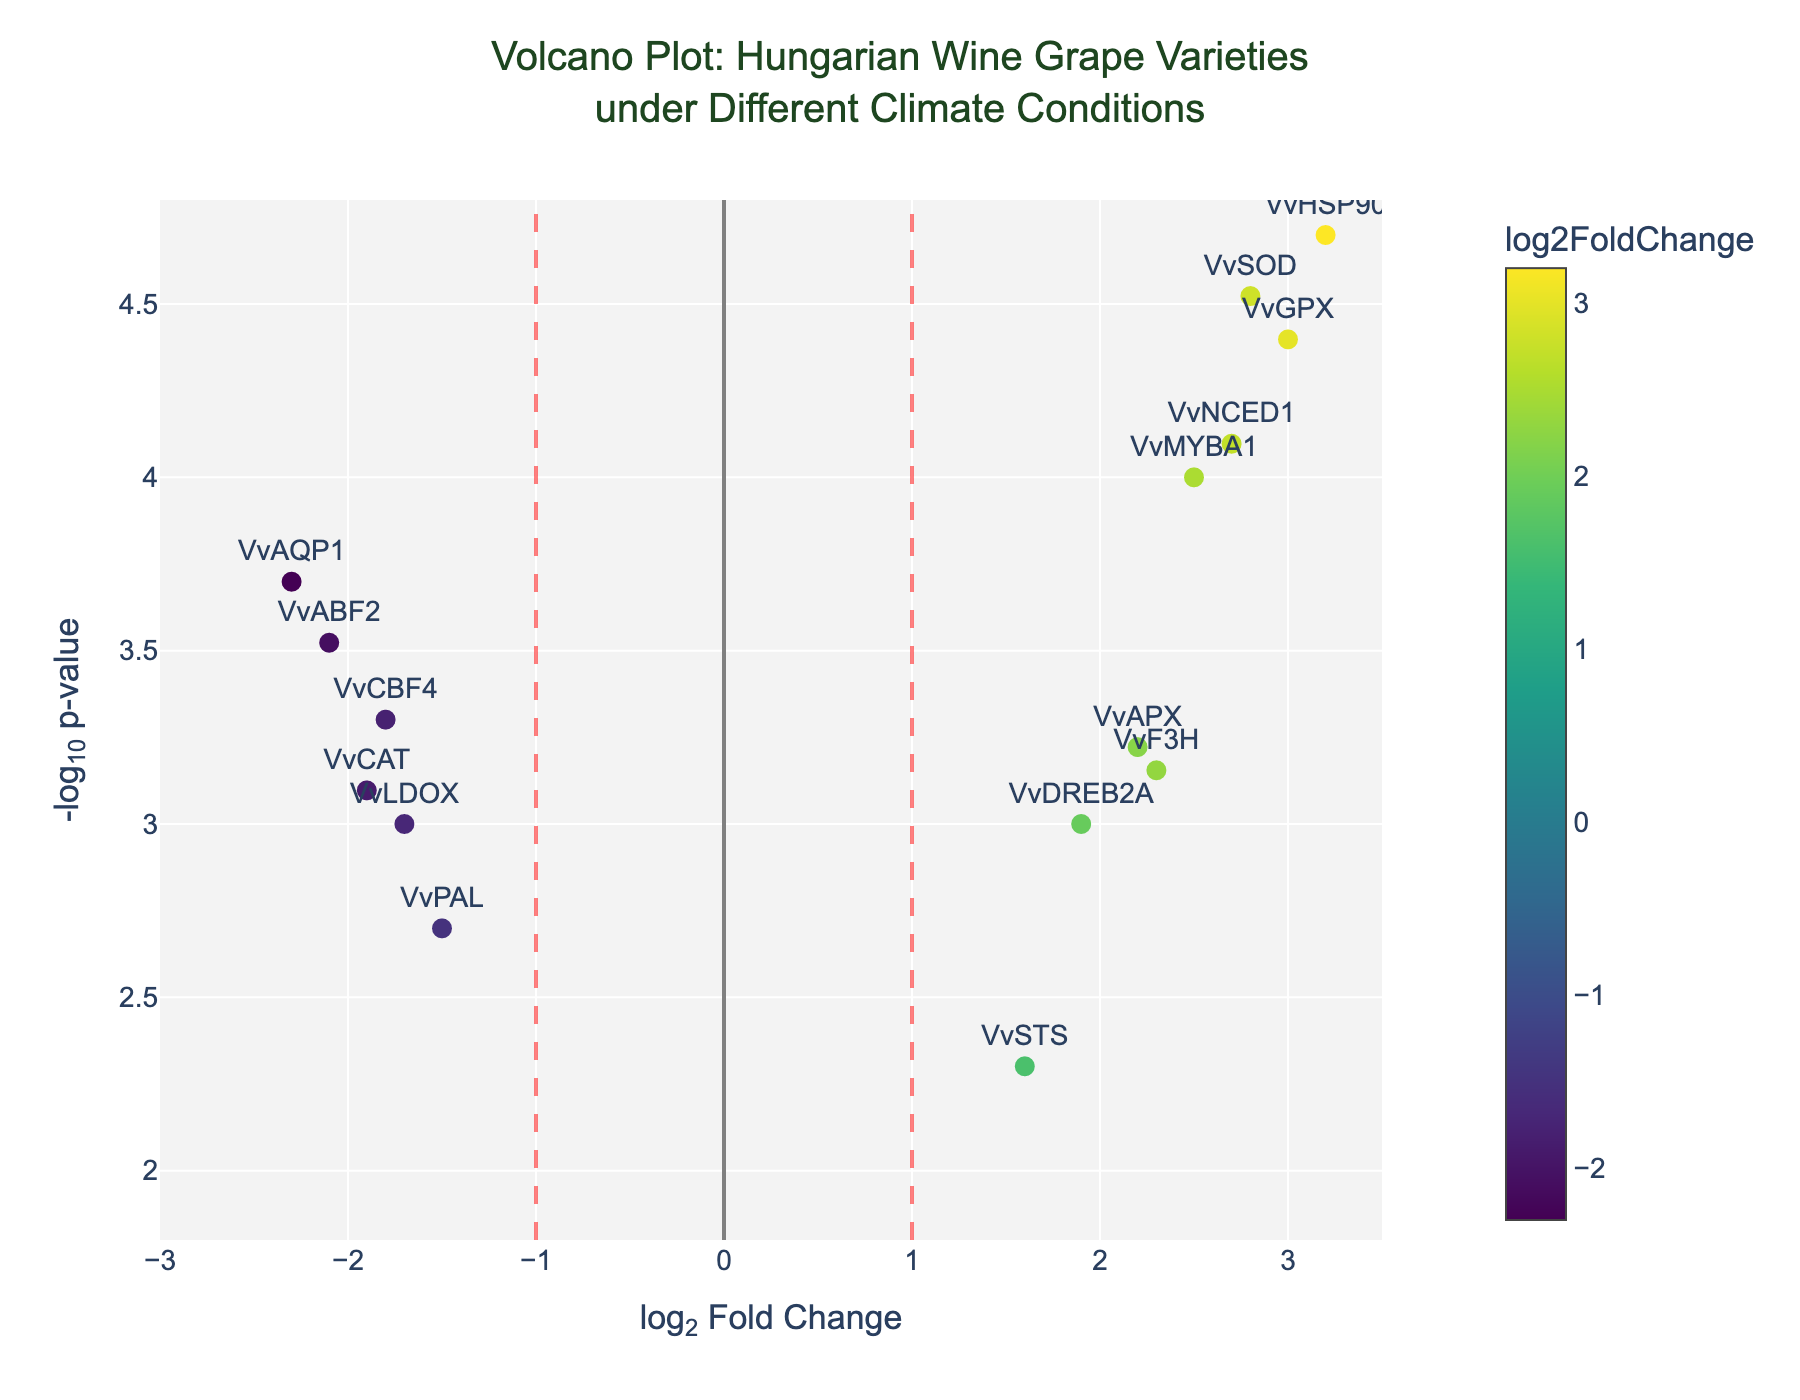What's the overall title of the plot? The title is usually located at the top of the plot and summarizes the main topic. In this case, it is "Volcano Plot: Hungarian Wine Grape Varieties under Different Climate Conditions".
Answer: Volcano Plot: Hungarian Wine Grape Varieties under Different Climate Conditions What do the vertical red dashed lines at x = -1 and x = 1 represent? These lines typically represent threshold values for the log2 fold change. Genes with values beyond these lines are considered significantly up- or down-regulated.
Answer: Threshold for log2 fold change Which gene has the highest log2 fold change? The gene with the highest log2 fold change can be identified as the point farthest to the right. According to the data, VvHSP90 has the highest log2 fold change at 3.2.
Answer: VvHSP90 What does the color scale in the plot represent? The color scale, usually shown as a gradient bar, represents the log2 fold change values, with different colors indicating the range of these values.
Answer: log2 fold change At what p-value threshold is the horizontal red dashed line drawn? The horizontal red dashed line is drawn at a p-value threshold indicated by -log10(p-value) = -log10(0.05). This threshold is where -log10(0.05) ≈ 1.3.
Answer: -log10(0.05) How many genes have a log2 fold change greater than 2 and a p-value smaller than 0.001? We need to count all the points with log2FoldChange > 2 and -log10(pvalue) > 3. These genes are VvHSP90, VvNCED1, VvGPX, and VvSOD.
Answer: 4 Which gene has the lowest p-value? The gene with the lowest p-value will have the highest -log10(pvalue) value. According to the data, VvHSP90 has the lowest p-value (smallest numerical value) at 0.00002.
Answer: VvHSP90 What is the log2 fold change and p-value for the VvABF2 gene? The plot provides hover text for each gene detailing these values. For VvABF2, the log2 fold change is -2.1 and the p-value is 0.0003.
Answer: log2 fold change: -2.1, p-value: 0.0003 Which genes are considered significantly up-regulated? Genes are considered significantly up-regulated if their log2 fold change is greater than 1 and their p-value is lower than 0.05. These genes are VvMYBA1, VvHSP90, VvNCED1, VvF3H, VvAPX, VvGPX, and VvSOD.
Answer: VvMYBA1, VvHSP90, VvNCED1, VvF3H, VvAPX, VvGPX, VvSOD Compare the p-value of VvDREB2A and VvSTS. Which one is lower? The p-values can be compared directly. VvDREB2A has a p-value of 0.001, while VvSTS has a p-value of 0.005. So, VvDREB2A has a lower p-value.
Answer: VvDREB2A 